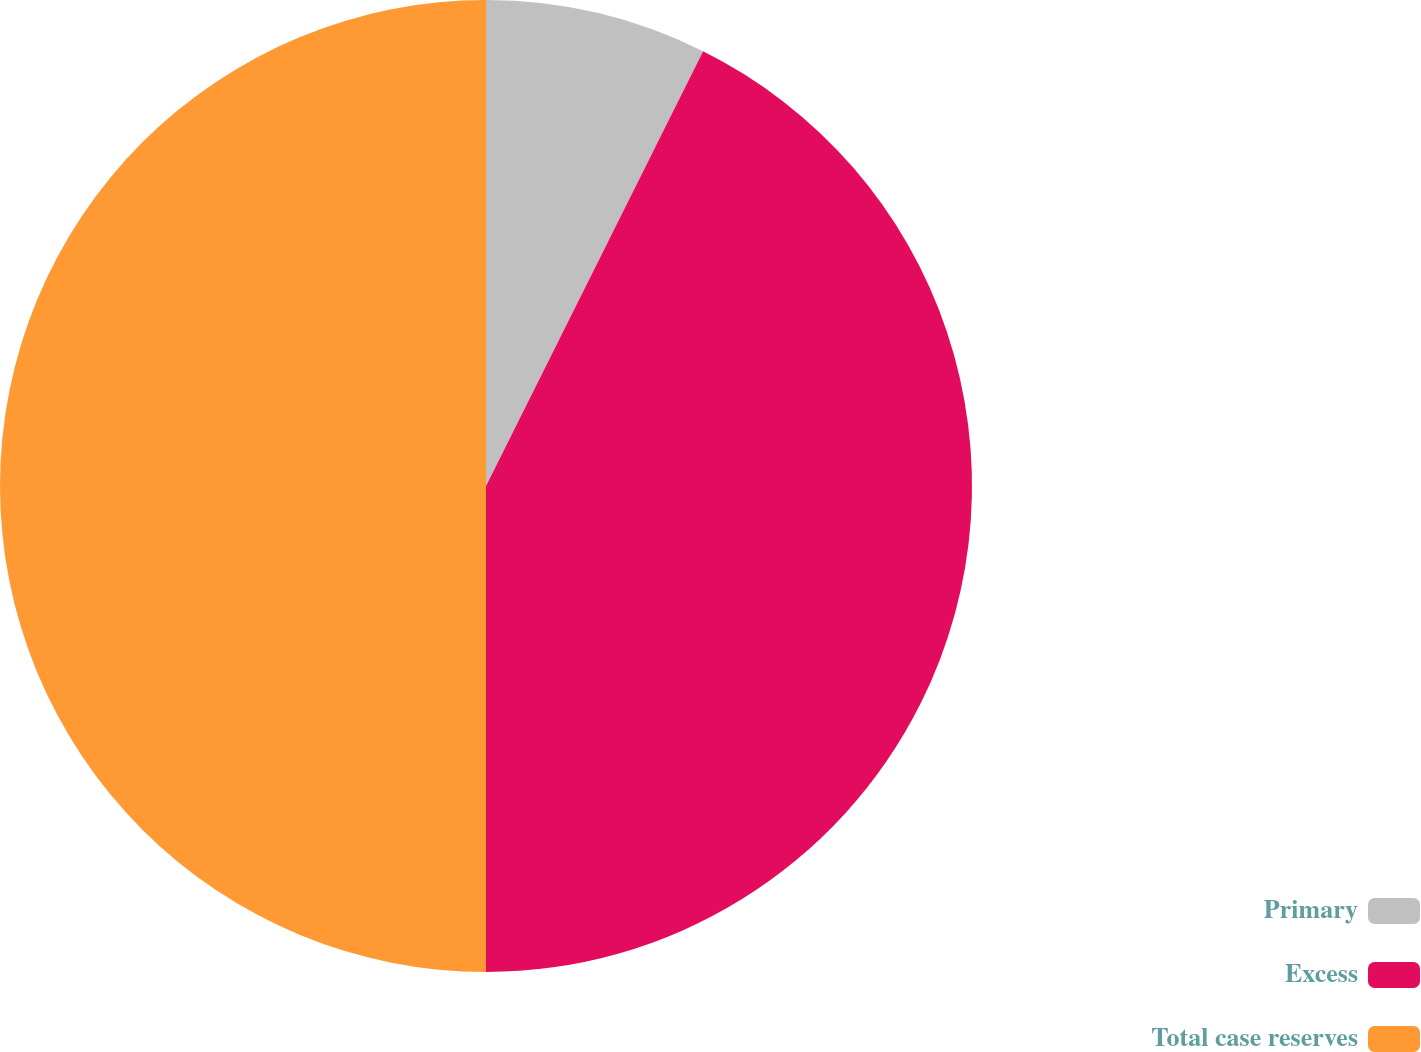Convert chart. <chart><loc_0><loc_0><loc_500><loc_500><pie_chart><fcel>Primary<fcel>Excess<fcel>Total case reserves<nl><fcel>7.37%<fcel>42.63%<fcel>50.0%<nl></chart> 